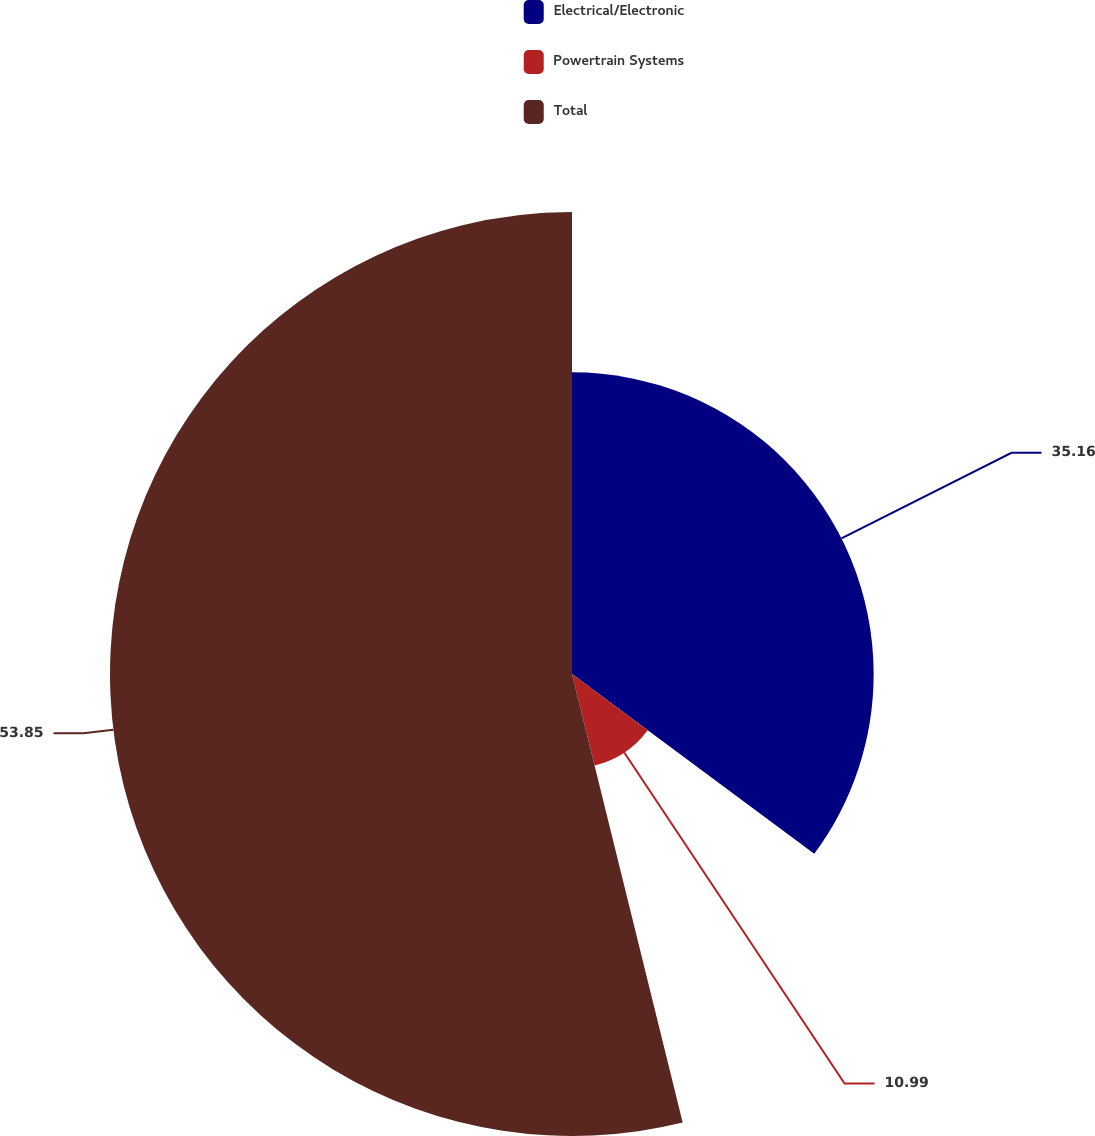Convert chart to OTSL. <chart><loc_0><loc_0><loc_500><loc_500><pie_chart><fcel>Electrical/Electronic<fcel>Powertrain Systems<fcel>Total<nl><fcel>35.16%<fcel>10.99%<fcel>53.85%<nl></chart> 